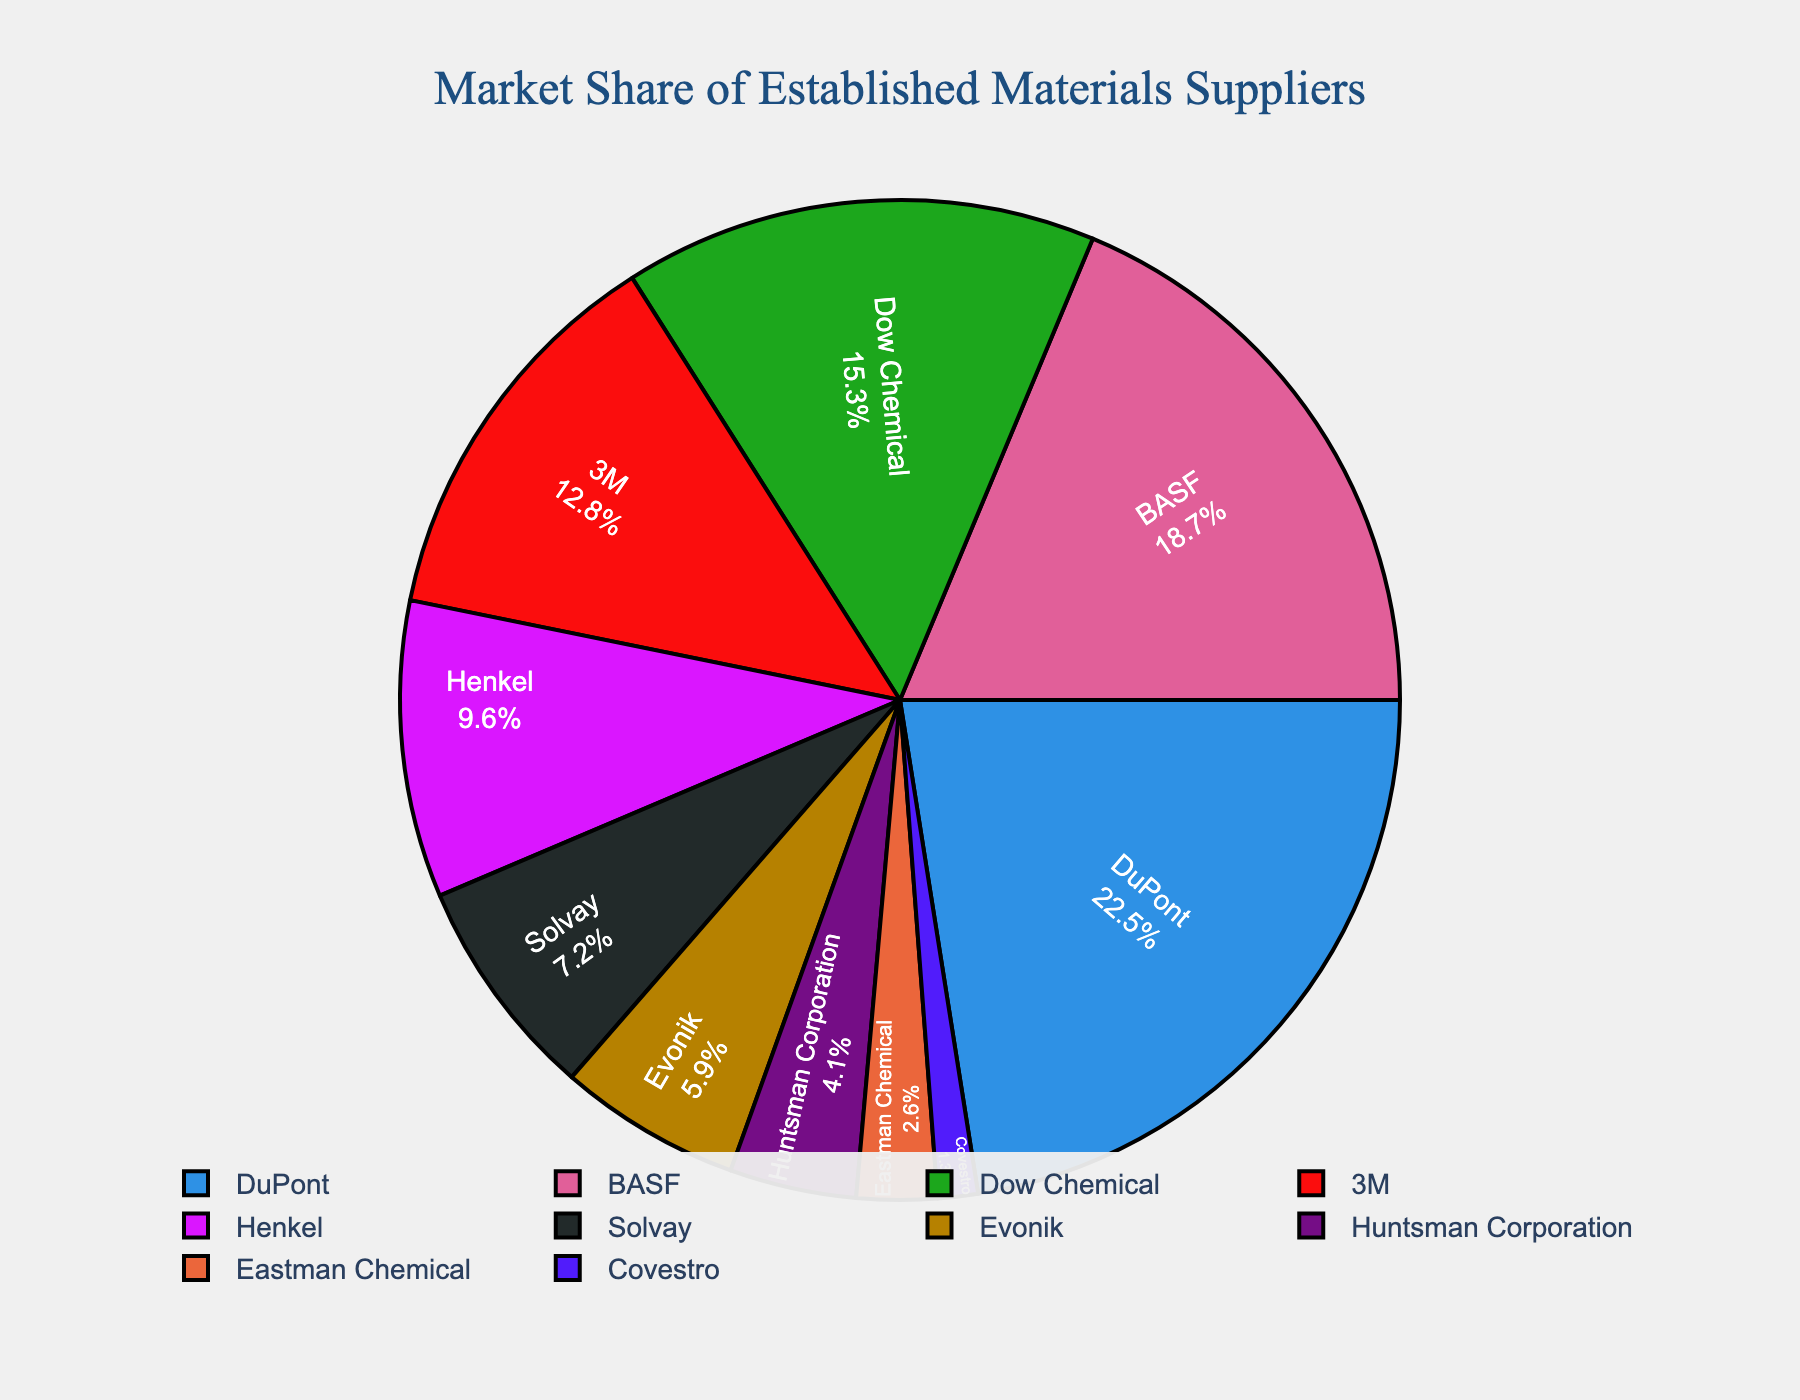What's the combined market share of DuPont and BASF? First, identify the market share of DuPont (22.5) and BASF (18.7). Then, add these two values: 22.5 + 18.7 = 41.2
Answer: 41.2 Which company has the smallest market share? From the pie chart, find the company with the smallest market share. Covestro has a market share of 1.3, which is the smallest among all listed companies.
Answer: Covestro Is Dow Chemical's market share greater than 3M's? Locate Dow Chemical's market share (15.3) and 3M's market share (12.8) on the chart. Since 15.3 is greater than 12.8, Dow Chemical's market share is indeed greater.
Answer: Yes What's the difference in market share between Henkel and Solvay? Find the market share values for Henkel (9.6) and Solvay (7.2). Subtract Solvay's market share from Henkel's: 9.6 - 7.2 = 2.4
Answer: 2.4 Which company has a larger market share: Evonik or Eastman Chemical? Compare the market shares for Evonik (5.9) and Eastman Chemical (2.6). Since 5.9 is greater than 2.6, Evonik has a larger market share.
Answer: Evonik What percentage of the market do the companies with a share above 10% hold combined? Sum the market shares of companies with more than 10% market share: DuPont (22.5), BASF (18.7), Dow Chemical (15.3), and 3M (12.8): 22.5 + 18.7 + 15.3 + 12.8 = 69.3
Answer: 69.3 What's the average market share of the listed companies? Sum all the market shares (22.5 + 18.7 + 15.3 + 12.8 + 9.6 + 7.2 + 5.9 + 4.1 + 2.6 + 1.3 = 100) and divide by the number of companies (10): 100 / 10 = 10
Answer: 10 What is the ratio of Dow Chemical's market share to Huntsman Corporation's market share? Find the market share values for Dow Chemical (15.3) and Huntsman Corporation (4.1). Calculate the ratio: 15.3 / 4.1 ≈ 3.73
Answer: 3.73 Which sector of the pie chart is the largest, and what is its market share? Identify the largest sector in the pie chart. DuPont has the largest market share at 22.5, so it occupies the largest sector.
Answer: DuPont, 22.5 